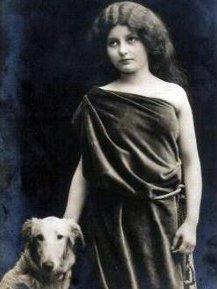How many dogs are in the photo?
Give a very brief answer. 1. 